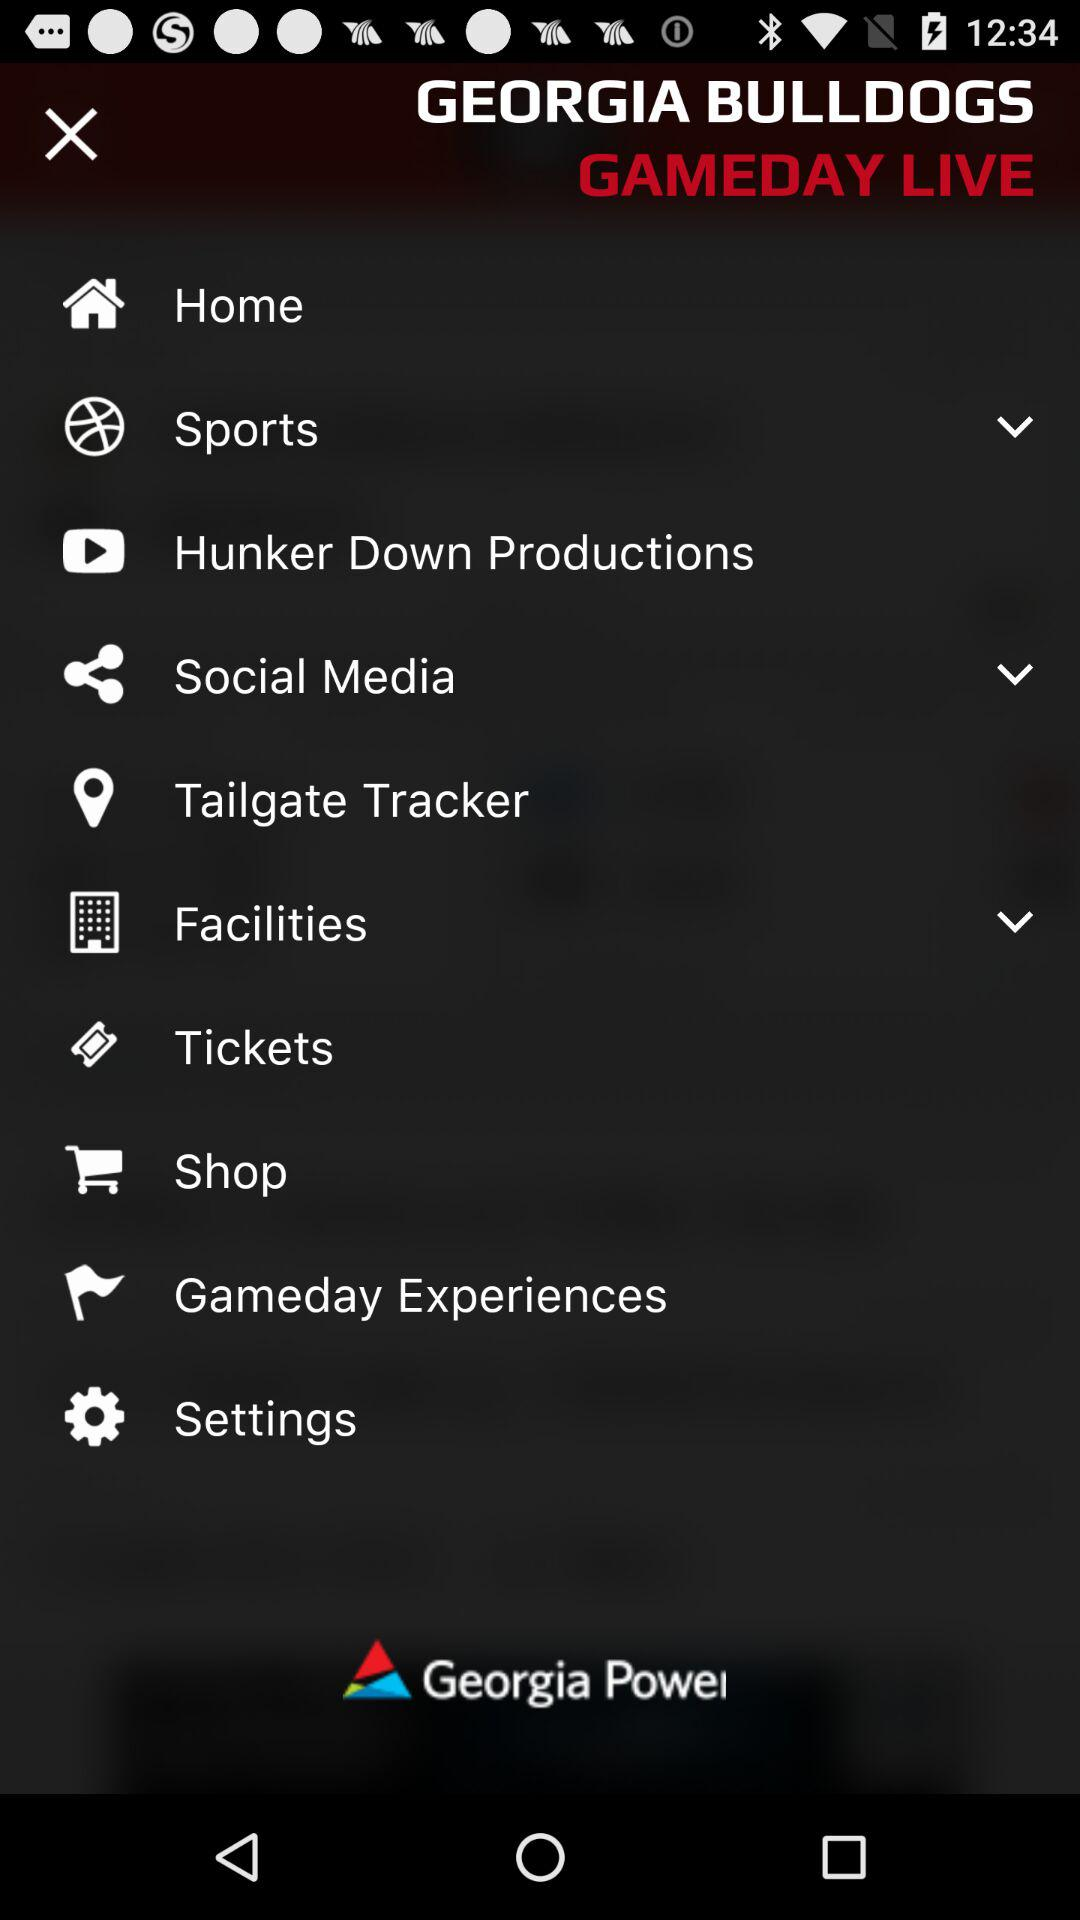Who is the developer?
When the provided information is insufficient, respond with <no answer>. <no answer> 